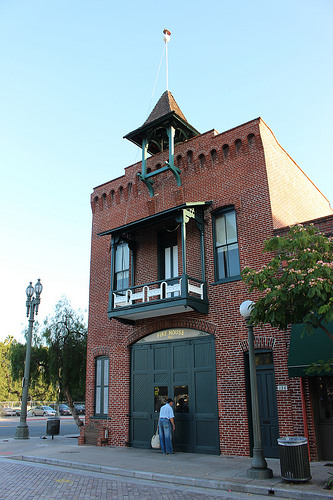<image>
Is there a railing above the man? Yes. The railing is positioned above the man in the vertical space, higher up in the scene. 